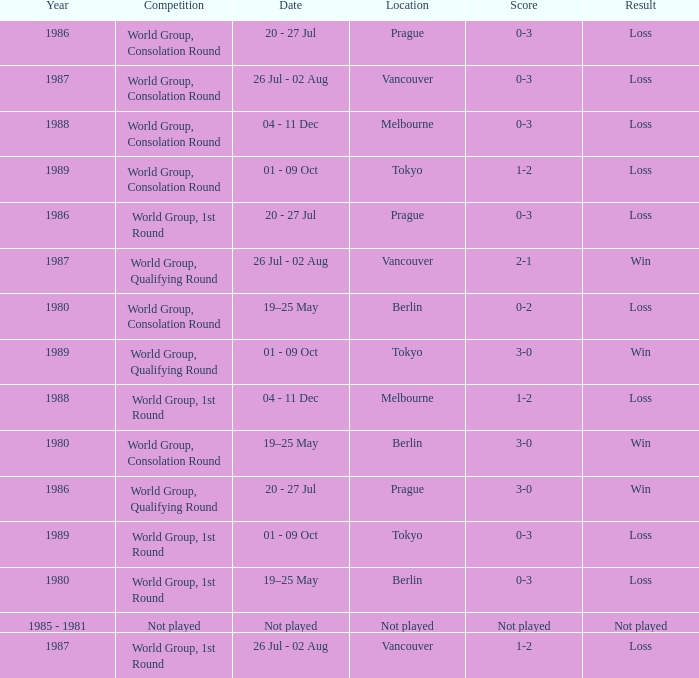Could you parse the entire table? {'header': ['Year', 'Competition', 'Date', 'Location', 'Score', 'Result'], 'rows': [['1986', 'World Group, Consolation Round', '20 - 27 Jul', 'Prague', '0-3', 'Loss'], ['1987', 'World Group, Consolation Round', '26 Jul - 02 Aug', 'Vancouver', '0-3', 'Loss'], ['1988', 'World Group, Consolation Round', '04 - 11 Dec', 'Melbourne', '0-3', 'Loss'], ['1989', 'World Group, Consolation Round', '01 - 09 Oct', 'Tokyo', '1-2', 'Loss'], ['1986', 'World Group, 1st Round', '20 - 27 Jul', 'Prague', '0-3', 'Loss'], ['1987', 'World Group, Qualifying Round', '26 Jul - 02 Aug', 'Vancouver', '2-1', 'Win'], ['1980', 'World Group, Consolation Round', '19–25 May', 'Berlin', '0-2', 'Loss'], ['1989', 'World Group, Qualifying Round', '01 - 09 Oct', 'Tokyo', '3-0', 'Win'], ['1988', 'World Group, 1st Round', '04 - 11 Dec', 'Melbourne', '1-2', 'Loss'], ['1980', 'World Group, Consolation Round', '19–25 May', 'Berlin', '3-0', 'Win'], ['1986', 'World Group, Qualifying Round', '20 - 27 Jul', 'Prague', '3-0', 'Win'], ['1989', 'World Group, 1st Round', '01 - 09 Oct', 'Tokyo', '0-3', 'Loss'], ['1980', 'World Group, 1st Round', '19–25 May', 'Berlin', '0-3', 'Loss'], ['1985 - 1981', 'Not played', 'Not played', 'Not played', 'Not played', 'Not played'], ['1987', 'World Group, 1st Round', '26 Jul - 02 Aug', 'Vancouver', '1-2', 'Loss']]} What is the date for the game in prague for the world group, consolation round competition? 20 - 27 Jul. 